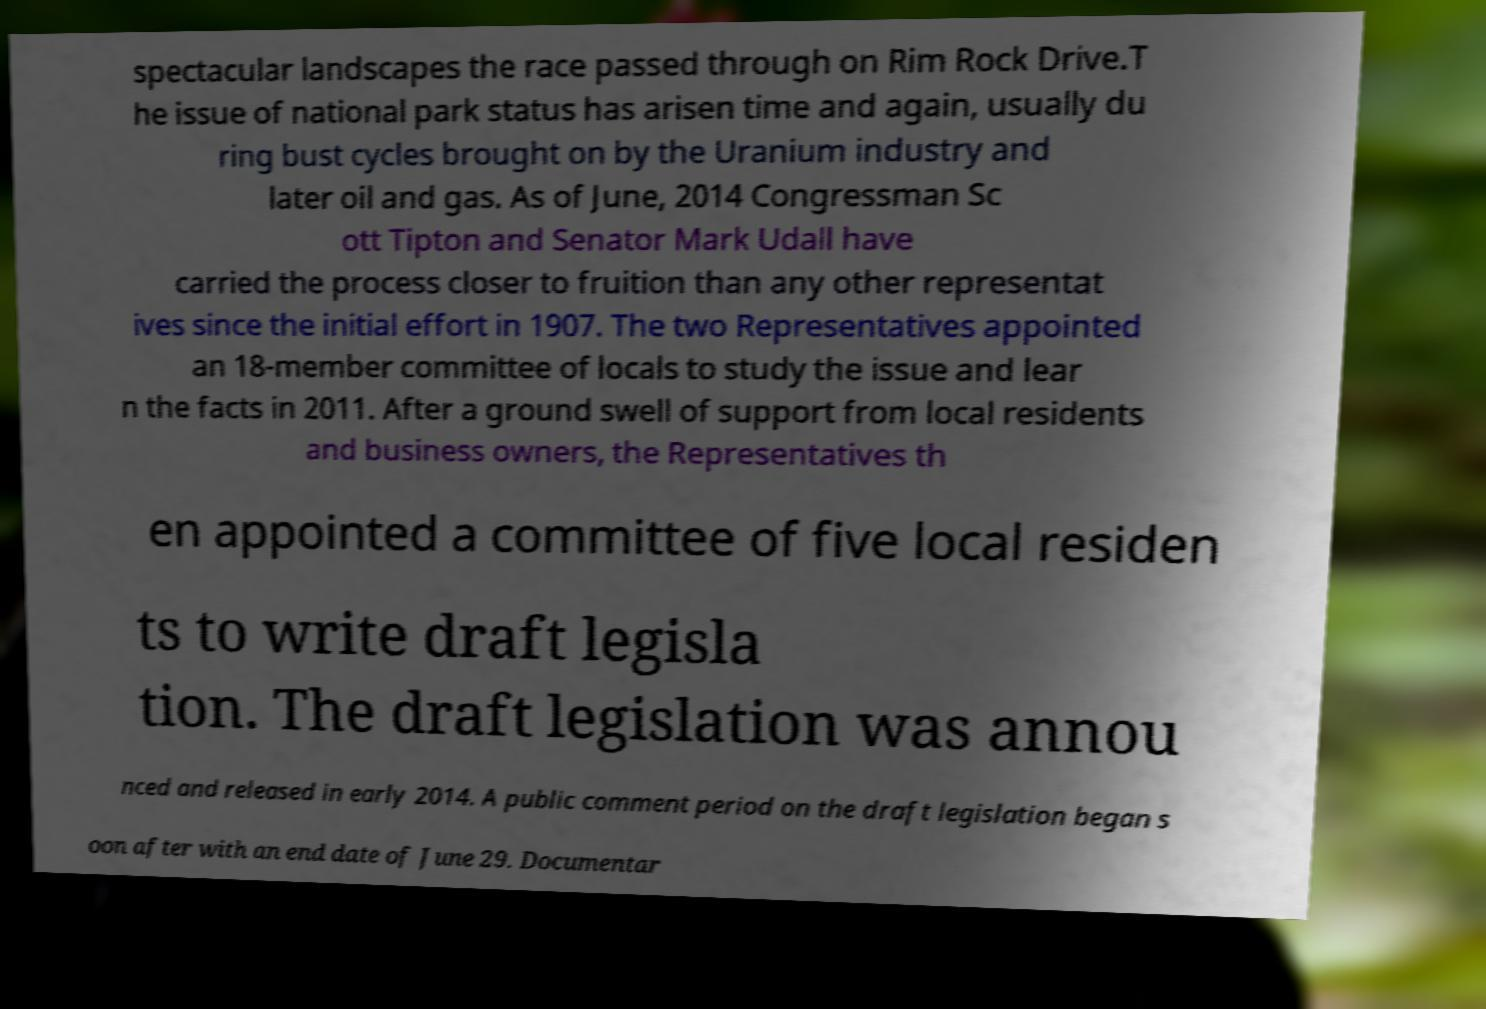There's text embedded in this image that I need extracted. Can you transcribe it verbatim? spectacular landscapes the race passed through on Rim Rock Drive.T he issue of national park status has arisen time and again, usually du ring bust cycles brought on by the Uranium industry and later oil and gas. As of June, 2014 Congressman Sc ott Tipton and Senator Mark Udall have carried the process closer to fruition than any other representat ives since the initial effort in 1907. The two Representatives appointed an 18-member committee of locals to study the issue and lear n the facts in 2011. After a ground swell of support from local residents and business owners, the Representatives th en appointed a committee of five local residen ts to write draft legisla tion. The draft legislation was annou nced and released in early 2014. A public comment period on the draft legislation began s oon after with an end date of June 29. Documentar 